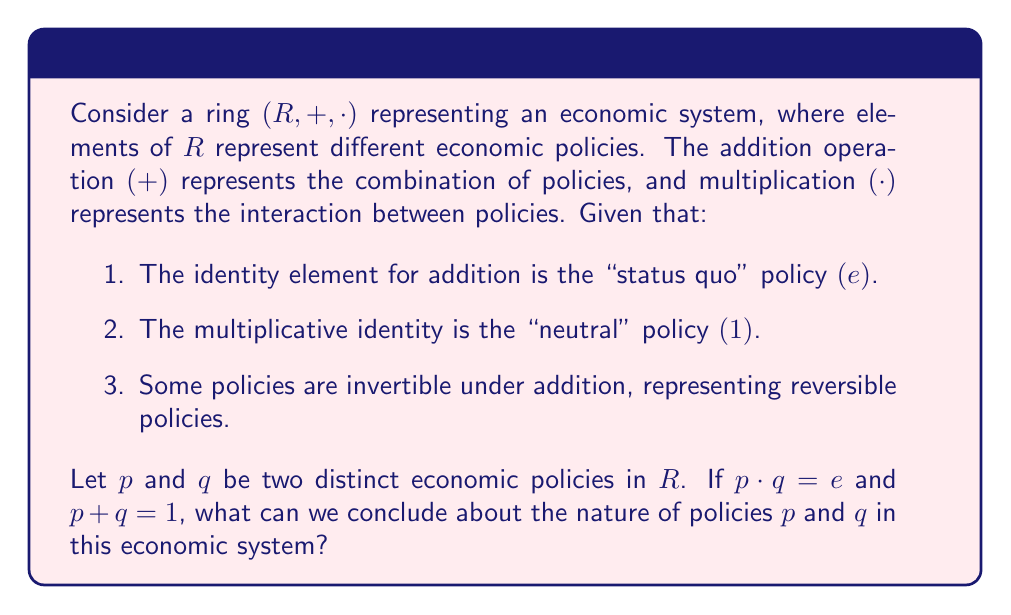Give your solution to this math problem. To analyze this problem, let's consider the properties of the ring $(R, +, \cdot)$ and interpret them in the context of economic policies:

1. First, we have $p \cdot q = e$. In ring theory, this means that $p$ and $q$ are zero divisors, as their product results in the additive identity. In our economic interpretation, this suggests that the interaction of policies $p$ and $q$ effectively cancels out any change, resulting in the "status quo."

2. We also have $p + q = 1$. In ring theory, this means that $p$ and $q$ are additive inverses of each other, shifted by the multiplicative identity. In economic terms, this implies that combining policies $p$ and $q$ results in the "neutral" policy.

3. Since $p + q = 1$ and not $e$, we know that $1 \neq e$ in this ring. This means that the "neutral" policy is distinct from the "status quo" policy.

4. The existence of additive inverses for some elements suggests that some policies can be reversed or counteracted.

5. The fact that $p$ and $q$ satisfy both equations simultaneously implies that they are complementary policies that interact in a way that maintains the status quo, but when combined, they shift the system to a neutral state.

6. These properties suggest that $p$ and $q$ represent policies that are:
   a) Opposing or counterbalancing in their effects (due to their additive inverse relationship)
   b) Mutually nullifying in their interaction (due to their multiplicative zero divisor property)
   c) Complementary in achieving a neutral state when combined

This type of relationship between policies could be useful for a government official evaluating the effectiveness of societal reforms, as it highlights the complex interactions between different economic policies and the importance of considering both their individual and combined effects.
Answer: Policies $p$ and $q$ are complementary economic policies that:
1) Are additive inverses of each other (shifted by the neutral policy)
2) Act as zero divisors when multiplied
3) Counterbalance each other's effects
4) Produce a neutral state when combined
5) Maintain the status quo when they interact 